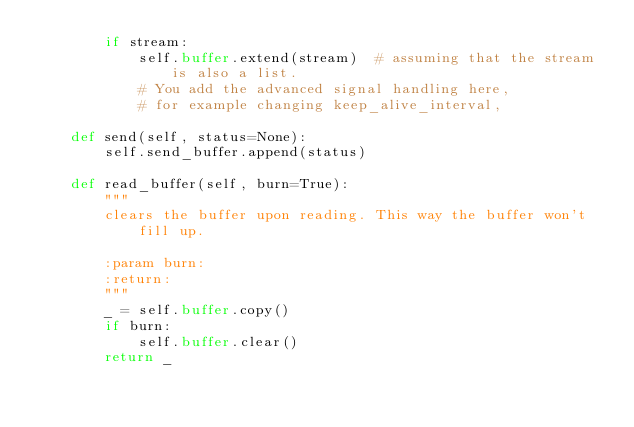Convert code to text. <code><loc_0><loc_0><loc_500><loc_500><_Python_>        if stream:
            self.buffer.extend(stream)  # assuming that the stream is also a list.
            # You add the advanced signal handling here,
            # for example changing keep_alive_interval,

    def send(self, status=None):
        self.send_buffer.append(status)

    def read_buffer(self, burn=True):
        """
        clears the buffer upon reading. This way the buffer won't fill up.
        
        :param burn:
        :return:
        """
        _ = self.buffer.copy()
        if burn:
            self.buffer.clear()
        return _
</code> 